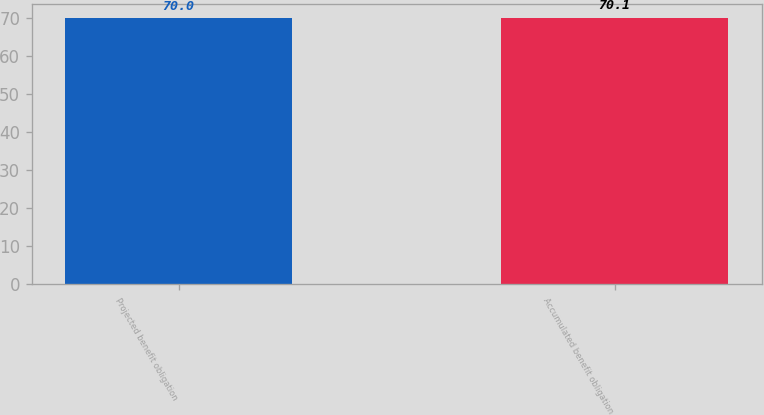Convert chart. <chart><loc_0><loc_0><loc_500><loc_500><bar_chart><fcel>Projected benefit obligation<fcel>Accumulated benefit obligation<nl><fcel>70<fcel>70.1<nl></chart> 